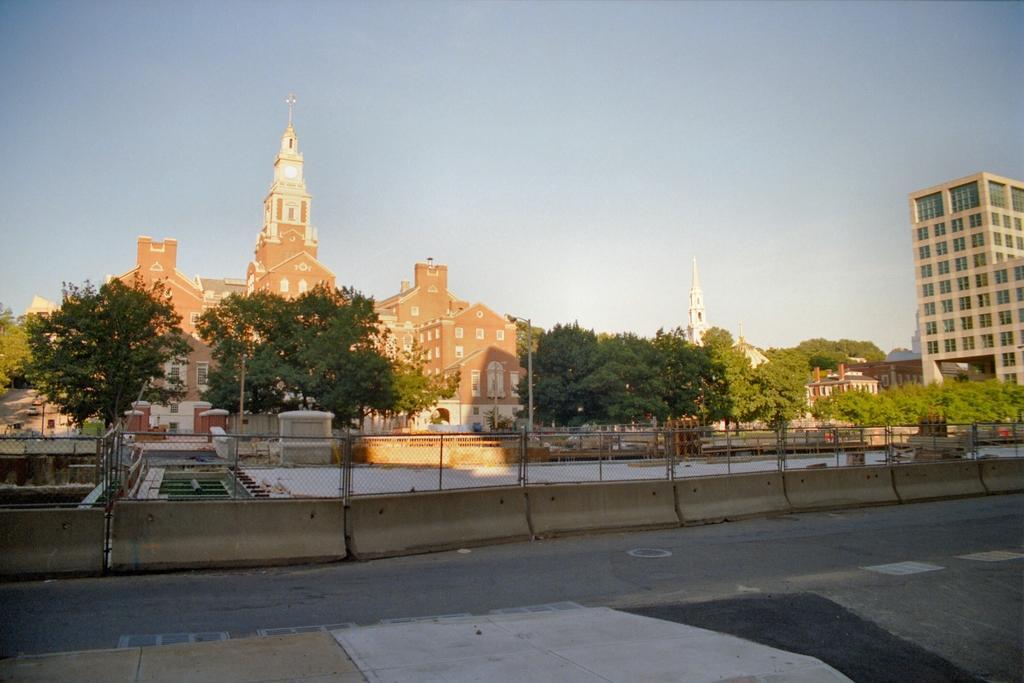In one or two sentences, can you explain what this image depicts? Here in this picture we can see a church and other number of buildings present over there and we can see plants and trees present here and there and in the middle we can see a railing present over there. 